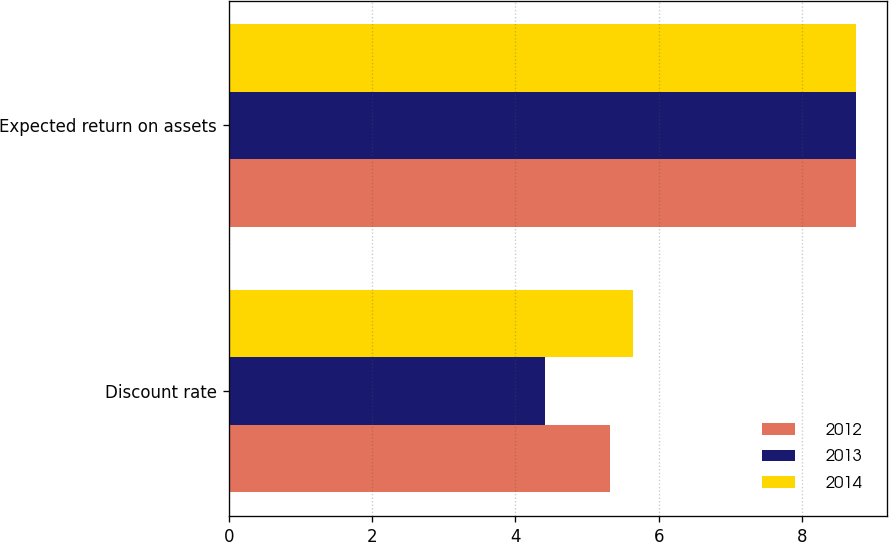Convert chart to OTSL. <chart><loc_0><loc_0><loc_500><loc_500><stacked_bar_chart><ecel><fcel>Discount rate<fcel>Expected return on assets<nl><fcel>2012<fcel>5.32<fcel>8.75<nl><fcel>2013<fcel>4.42<fcel>8.75<nl><fcel>2014<fcel>5.64<fcel>8.75<nl></chart> 